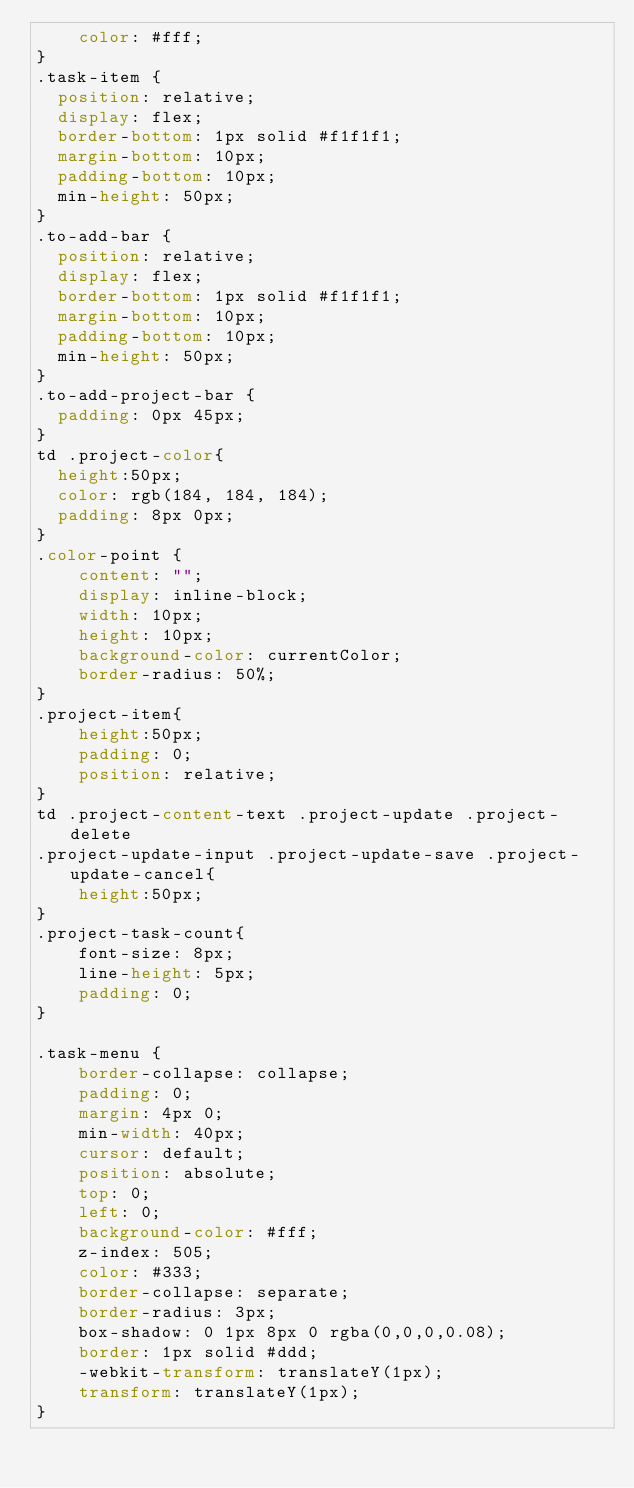Convert code to text. <code><loc_0><loc_0><loc_500><loc_500><_CSS_>    color: #fff;
}
.task-item {
  position: relative;
  display: flex;
  border-bottom: 1px solid #f1f1f1;
  margin-bottom: 10px;
  padding-bottom: 10px;
  min-height: 50px;
}
.to-add-bar {
  position: relative;
  display: flex;
  border-bottom: 1px solid #f1f1f1;
  margin-bottom: 10px;
  padding-bottom: 10px;
  min-height: 50px;
}
.to-add-project-bar {
  padding: 0px 45px;
}
td .project-color{
  height:50px;
  color: rgb(184, 184, 184);
  padding: 8px 0px;
}
.color-point {
    content: "";
    display: inline-block;
    width: 10px;
    height: 10px;
    background-color: currentColor;
    border-radius: 50%;
}
.project-item{
    height:50px;
    padding: 0;
    position: relative;
}
td .project-content-text .project-update .project-delete 
.project-update-input .project-update-save .project-update-cancel{
    height:50px;
}
.project-task-count{
    font-size: 8px;
    line-height: 5px;
    padding: 0;
}
    
.task-menu {
    border-collapse: collapse;
    padding: 0;
    margin: 4px 0;
    min-width: 40px;
    cursor: default;
    position: absolute;
    top: 0;
    left: 0;
    background-color: #fff;
    z-index: 505;
    color: #333;
    border-collapse: separate;
    border-radius: 3px;
    box-shadow: 0 1px 8px 0 rgba(0,0,0,0.08);
    border: 1px solid #ddd;
    -webkit-transform: translateY(1px);
    transform: translateY(1px);
}
</code> 